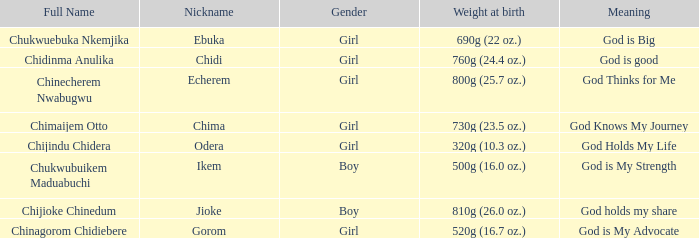5 oz.)? Chima. 